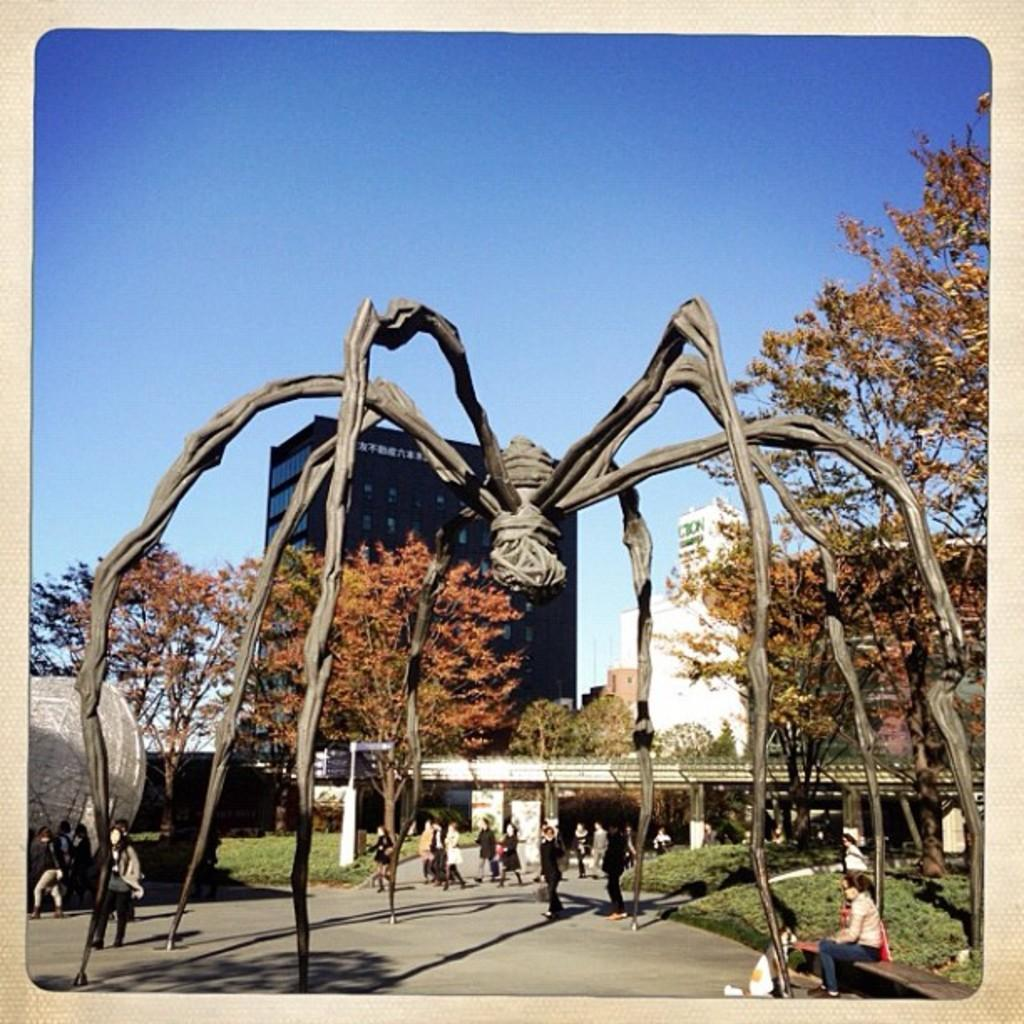How many people are in the image? There is a group of people standing in the image. What type of natural elements can be seen in the image? There are plants, grass, and trees in the image. What type of man-made structures are present in the image? There are buildings and boards in the image. What unique feature can be found in the image? There is a sculpture of a giant spider in the image. What is visible in the sky in the image? The sky is visible in the image. Can you tell me the price of the receipt for the canvas in the image? There is no canvas or receipt present in the image. What time is displayed on the clock in the image? There is no clock present in the image. 